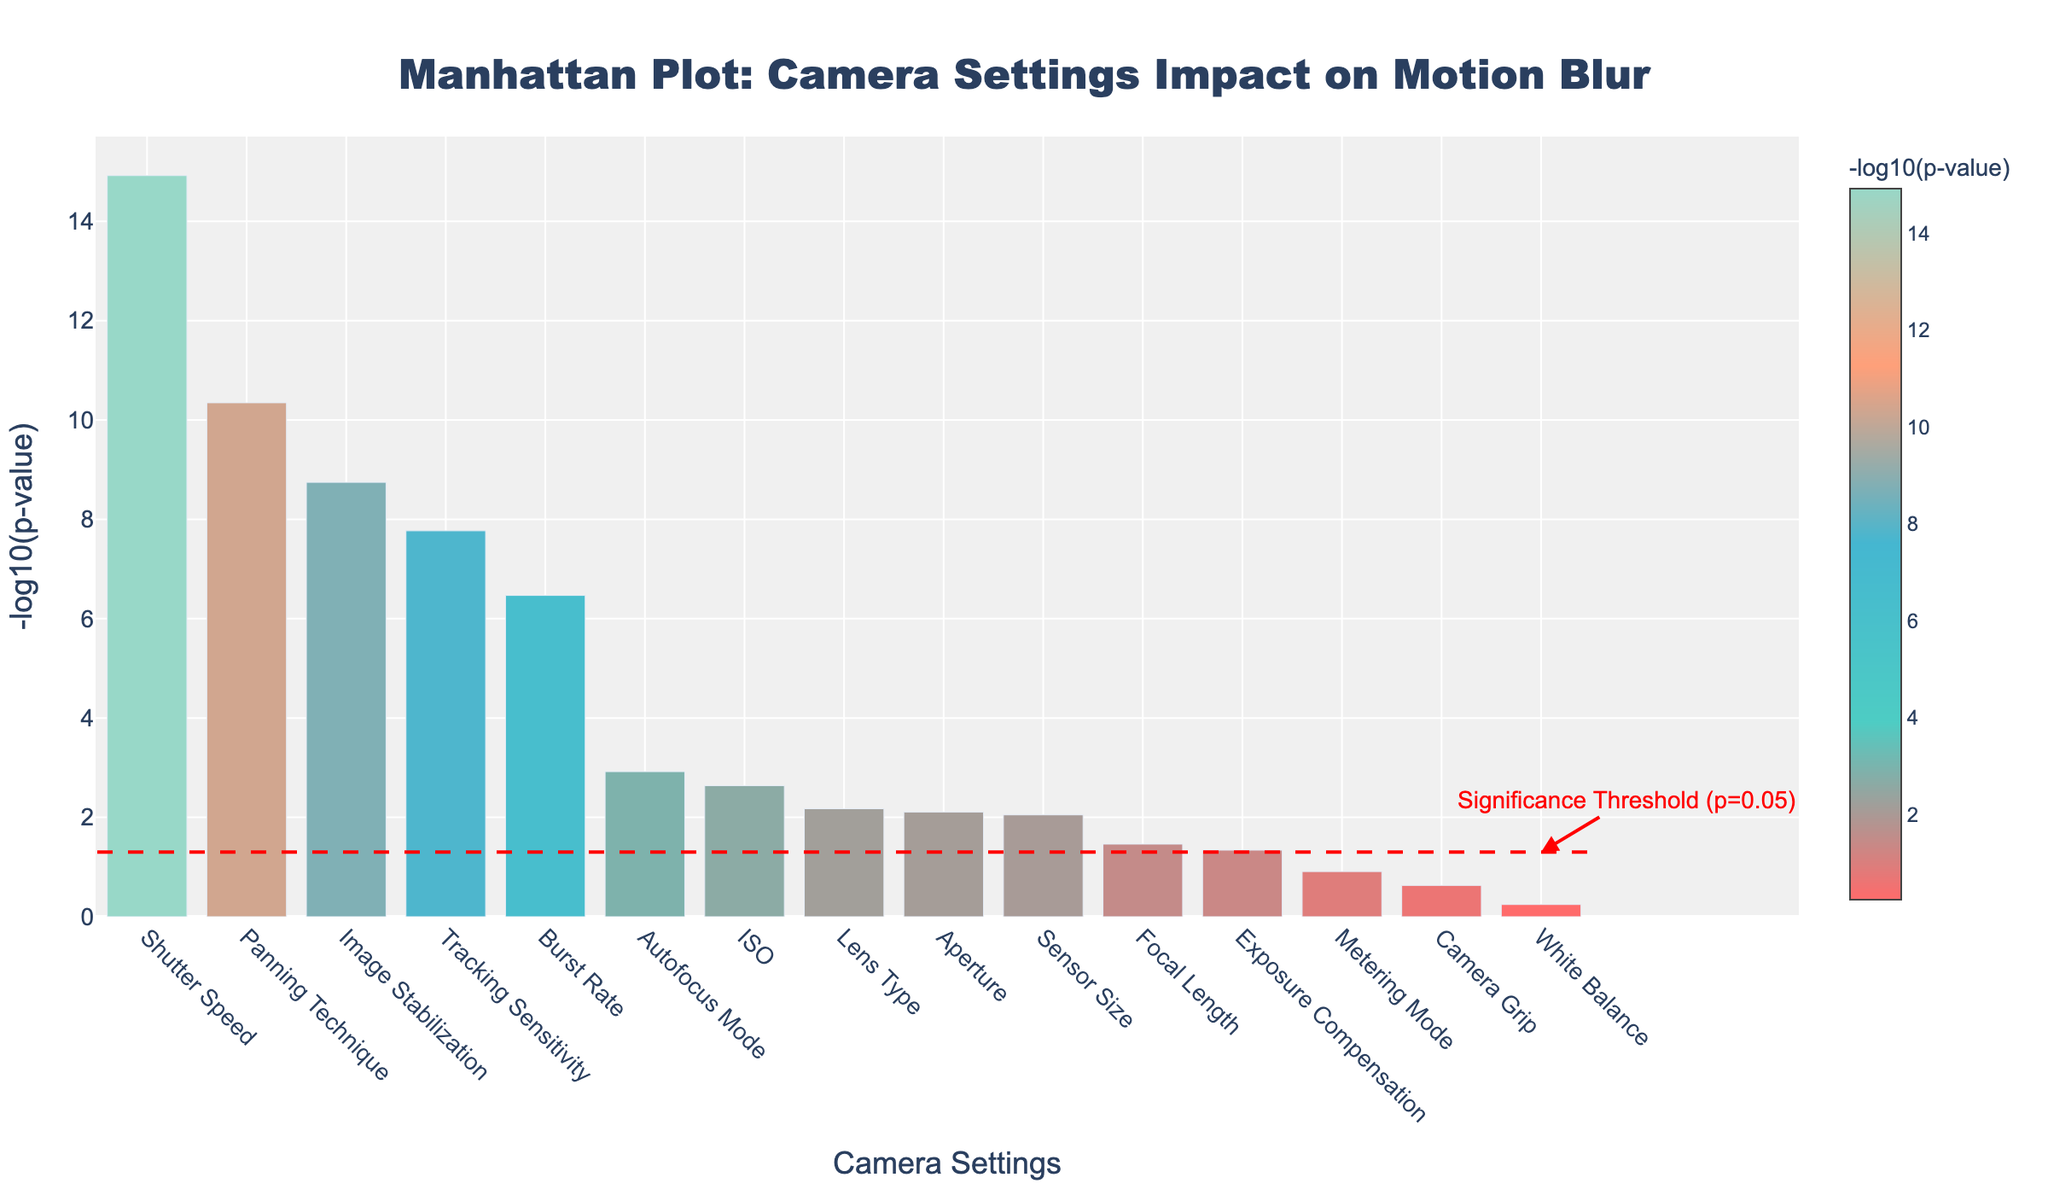Which camera setting has the lowest p-value? To determine which camera setting has the lowest p-value, look for the bar that reaches highest on the y-axis, because a lower p-value will result in a higher -log10(p) value. The bar for Shutter Speed is the highest.
Answer: Shutter Speed What is the title of the plot? The title is usually located at the top center of the plot. In this plot, the title reads 'Manhattan Plot: Camera Settings Impact on Motion Blur'.
Answer: Manhattan Plot: Camera Settings Impact on Motion Blur How many camera settings have a p-value less than 0.05? To find the number of camera settings with a p-value less than 0.05, locate the horizontal dashed red line representing the significance threshold. Count the bars that exceed this line. From the plot, it is clear that there are 9 settings above the threshold line.
Answer: 9 Which setting has the highest -log10(p-value) after Shutter Speed? After identifying Shutter Speed as having the highest value, look for the next highest bar. The bar for Image Stabilization is second highest.
Answer: Image Stabilization What does the horizontal red dashed line represent? The horizontal red dashed line signifies the significance threshold, often set at a p-value of 0.05. This line helps distinguish which settings have statistically significant impacts.
Answer: Significance threshold (p=0.05) Compare the -log10(p-value) of 'ISO' and 'Metering Mode'. Which is higher? To compare the -log10(p-value) of 'ISO' and 'Metering Mode', look at the height of the respective bars. The bar for ISO is higher than that of Metering Mode.
Answer: ISO What is the -log10(p-value) for Burst Rate? To find this value, locate the Burst Rate bar and check its height on the y-axis. The value is just under 7, as indicated by the hover text (around 6.47).
Answer: ~6.47 Does Focal Length have a statistically significant impact on motion blur? Check if the bar for Focal Length surpasses the horizontal red dashed line representing the significance threshold. The bar for Focal Length is below this line.
Answer: No How many camera settings have a -log10(p-value) greater than 5? Bars exceeding the -log10(p) value of 5 can be counted directly. From the plot, there are 4 settings with bars above this threshold (Shutter Speed, Image Stabilization, Panning Technique, Burst Rate).
Answer: 4 What is the significance threshold in terms of -log10(p-value)? Find the y-axis level of the horizontal red dashed line to determine the -log10 of the significance threshold. The threshold (p = 0.05) corresponds approximately to 1.3 on the -log10(p) scale.
Answer: ~1.3 